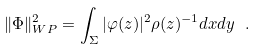<formula> <loc_0><loc_0><loc_500><loc_500>\| \Phi \| ^ { 2 } _ { W P } = \int _ { \Sigma } | \varphi ( z ) | ^ { 2 } \rho ( z ) ^ { - 1 } d x d y \ .</formula> 